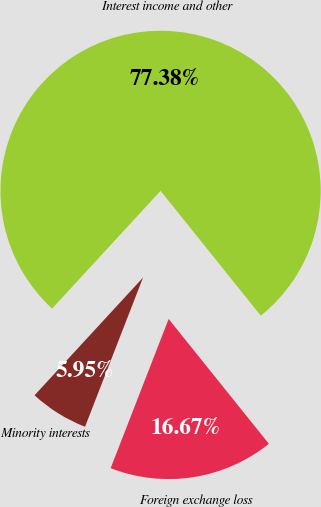Convert chart. <chart><loc_0><loc_0><loc_500><loc_500><pie_chart><fcel>Interest income and other<fcel>Minority interests<fcel>Foreign exchange loss<nl><fcel>77.38%<fcel>5.95%<fcel>16.67%<nl></chart> 